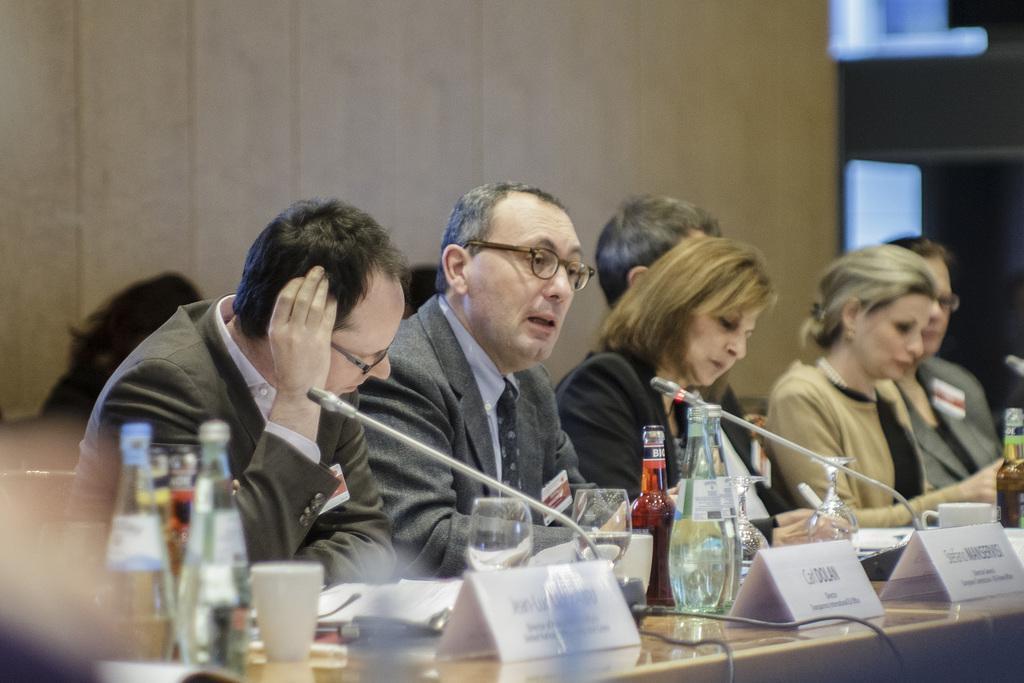How would you summarize this image in a sentence or two? This image is taken indoors. In the background there is a wall. At the bottom of the image there is a table with a few name boards and many things on it. In the middle of the image a few people are sitting on the chairs and writing on the papers. 